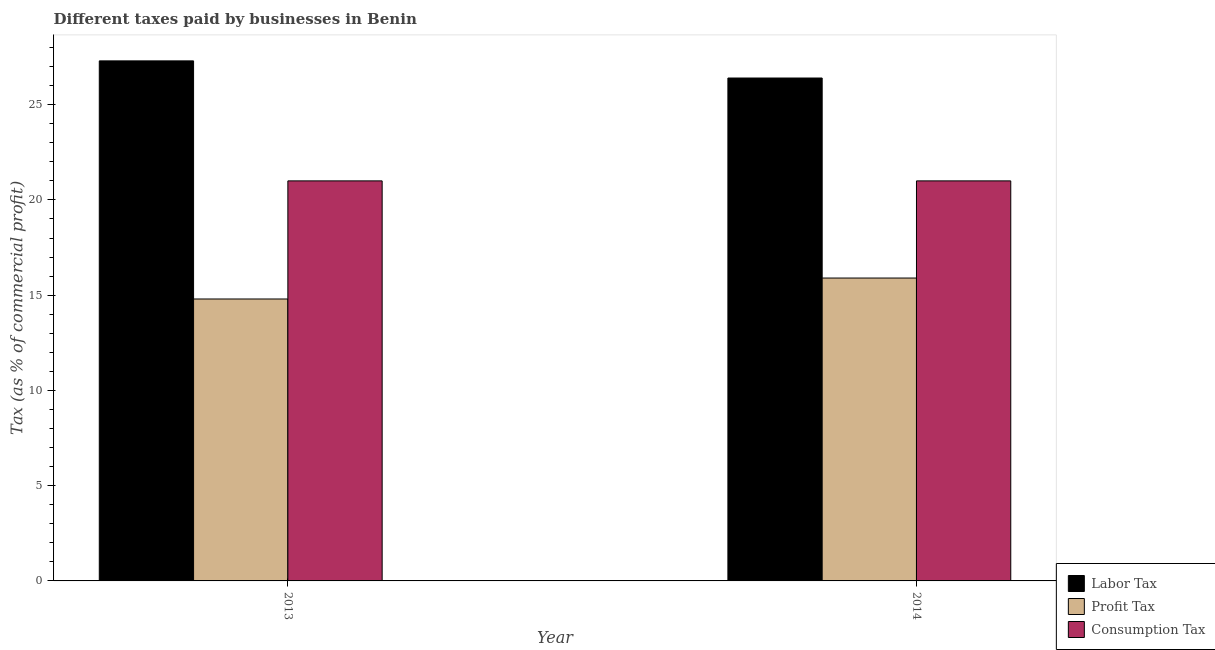How many groups of bars are there?
Provide a succinct answer. 2. How many bars are there on the 1st tick from the left?
Keep it short and to the point. 3. How many bars are there on the 1st tick from the right?
Offer a very short reply. 3. What is the label of the 1st group of bars from the left?
Provide a short and direct response. 2013. In how many cases, is the number of bars for a given year not equal to the number of legend labels?
Your response must be concise. 0. What is the percentage of profit tax in 2013?
Offer a very short reply. 14.8. Across all years, what is the maximum percentage of consumption tax?
Offer a terse response. 21. In which year was the percentage of profit tax maximum?
Offer a very short reply. 2014. What is the total percentage of consumption tax in the graph?
Provide a short and direct response. 42. What is the difference between the percentage of labor tax in 2013 and that in 2014?
Offer a very short reply. 0.9. What is the difference between the percentage of profit tax in 2014 and the percentage of labor tax in 2013?
Ensure brevity in your answer.  1.1. In how many years, is the percentage of profit tax greater than 23 %?
Your answer should be very brief. 0. Is the percentage of profit tax in 2013 less than that in 2014?
Your answer should be compact. Yes. What does the 1st bar from the left in 2013 represents?
Ensure brevity in your answer.  Labor Tax. What does the 3rd bar from the right in 2013 represents?
Make the answer very short. Labor Tax. Is it the case that in every year, the sum of the percentage of labor tax and percentage of profit tax is greater than the percentage of consumption tax?
Your response must be concise. Yes. Are all the bars in the graph horizontal?
Give a very brief answer. No. Does the graph contain any zero values?
Offer a very short reply. No. Does the graph contain grids?
Your answer should be very brief. No. What is the title of the graph?
Your answer should be compact. Different taxes paid by businesses in Benin. What is the label or title of the Y-axis?
Provide a succinct answer. Tax (as % of commercial profit). What is the Tax (as % of commercial profit) of Labor Tax in 2013?
Your answer should be compact. 27.3. What is the Tax (as % of commercial profit) in Profit Tax in 2013?
Give a very brief answer. 14.8. What is the Tax (as % of commercial profit) of Consumption Tax in 2013?
Ensure brevity in your answer.  21. What is the Tax (as % of commercial profit) in Labor Tax in 2014?
Keep it short and to the point. 26.4. What is the Tax (as % of commercial profit) of Consumption Tax in 2014?
Ensure brevity in your answer.  21. Across all years, what is the maximum Tax (as % of commercial profit) in Labor Tax?
Provide a short and direct response. 27.3. Across all years, what is the maximum Tax (as % of commercial profit) of Profit Tax?
Ensure brevity in your answer.  15.9. Across all years, what is the maximum Tax (as % of commercial profit) in Consumption Tax?
Your answer should be compact. 21. Across all years, what is the minimum Tax (as % of commercial profit) of Labor Tax?
Give a very brief answer. 26.4. Across all years, what is the minimum Tax (as % of commercial profit) in Profit Tax?
Your answer should be compact. 14.8. What is the total Tax (as % of commercial profit) in Labor Tax in the graph?
Make the answer very short. 53.7. What is the total Tax (as % of commercial profit) of Profit Tax in the graph?
Your answer should be compact. 30.7. What is the difference between the Tax (as % of commercial profit) of Labor Tax in 2013 and that in 2014?
Your answer should be compact. 0.9. What is the difference between the Tax (as % of commercial profit) in Profit Tax in 2013 and that in 2014?
Your answer should be very brief. -1.1. What is the difference between the Tax (as % of commercial profit) of Profit Tax in 2013 and the Tax (as % of commercial profit) of Consumption Tax in 2014?
Ensure brevity in your answer.  -6.2. What is the average Tax (as % of commercial profit) of Labor Tax per year?
Make the answer very short. 26.85. What is the average Tax (as % of commercial profit) in Profit Tax per year?
Your answer should be very brief. 15.35. What is the ratio of the Tax (as % of commercial profit) in Labor Tax in 2013 to that in 2014?
Provide a succinct answer. 1.03. What is the ratio of the Tax (as % of commercial profit) in Profit Tax in 2013 to that in 2014?
Your response must be concise. 0.93. What is the difference between the highest and the second highest Tax (as % of commercial profit) of Profit Tax?
Ensure brevity in your answer.  1.1. What is the difference between the highest and the lowest Tax (as % of commercial profit) of Labor Tax?
Your answer should be very brief. 0.9. What is the difference between the highest and the lowest Tax (as % of commercial profit) in Profit Tax?
Offer a terse response. 1.1. What is the difference between the highest and the lowest Tax (as % of commercial profit) of Consumption Tax?
Provide a short and direct response. 0. 